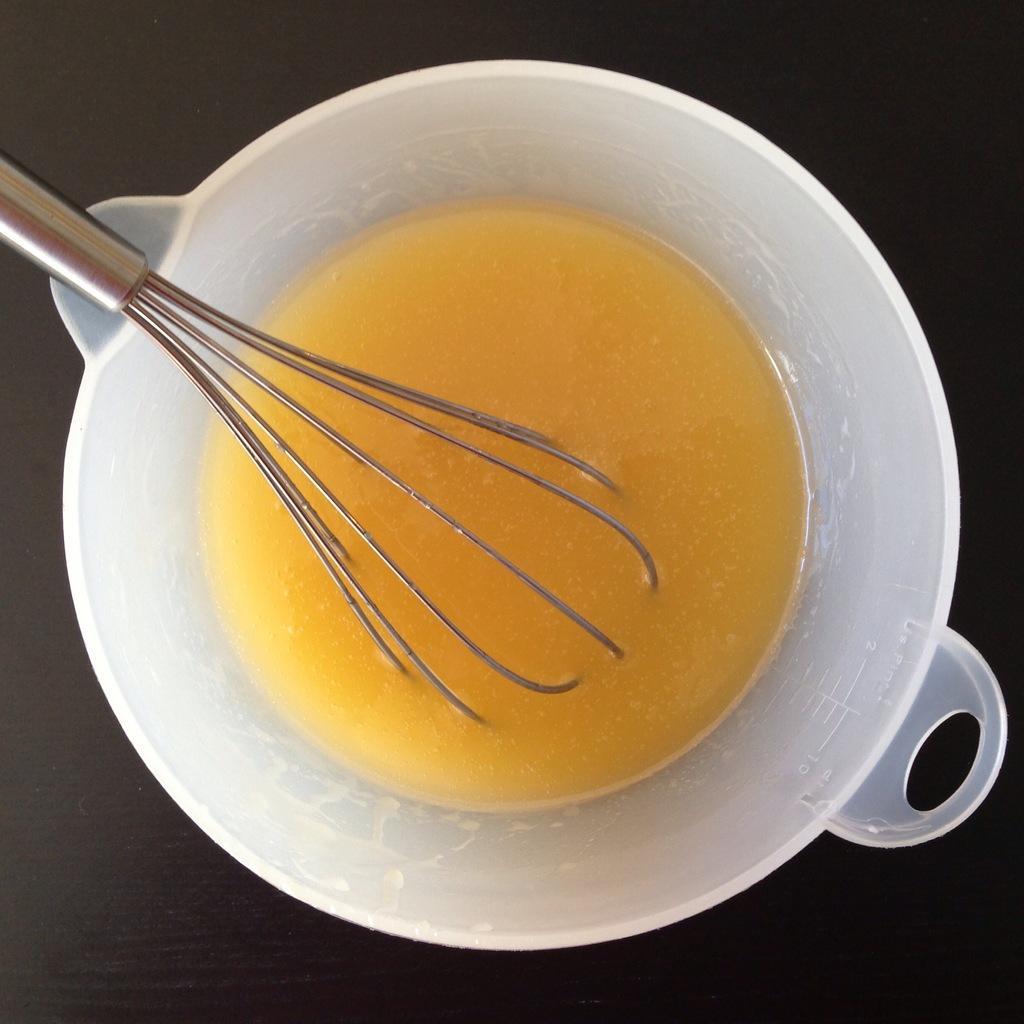Can you describe this image briefly? In this image I can see a bowl in which a whisked egg and a whisker is there. This image is taken in a room. 